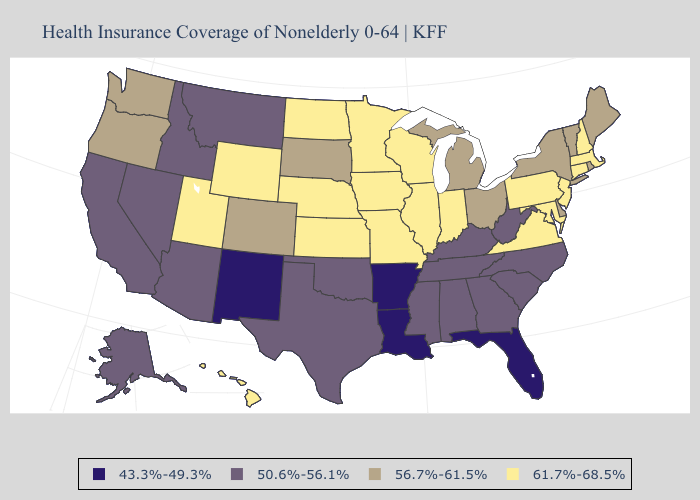What is the value of Montana?
Keep it brief. 50.6%-56.1%. Does the first symbol in the legend represent the smallest category?
Answer briefly. Yes. Name the states that have a value in the range 61.7%-68.5%?
Quick response, please. Connecticut, Hawaii, Illinois, Indiana, Iowa, Kansas, Maryland, Massachusetts, Minnesota, Missouri, Nebraska, New Hampshire, New Jersey, North Dakota, Pennsylvania, Utah, Virginia, Wisconsin, Wyoming. Among the states that border Arkansas , which have the highest value?
Concise answer only. Missouri. Does New York have the highest value in the Northeast?
Give a very brief answer. No. What is the highest value in states that border Oregon?
Answer briefly. 56.7%-61.5%. Does Arizona have a lower value than California?
Answer briefly. No. Does Idaho have the same value as Ohio?
Be succinct. No. What is the value of Montana?
Keep it brief. 50.6%-56.1%. Which states hav the highest value in the Northeast?
Write a very short answer. Connecticut, Massachusetts, New Hampshire, New Jersey, Pennsylvania. What is the value of Maryland?
Give a very brief answer. 61.7%-68.5%. Name the states that have a value in the range 61.7%-68.5%?
Quick response, please. Connecticut, Hawaii, Illinois, Indiana, Iowa, Kansas, Maryland, Massachusetts, Minnesota, Missouri, Nebraska, New Hampshire, New Jersey, North Dakota, Pennsylvania, Utah, Virginia, Wisconsin, Wyoming. What is the value of Virginia?
Give a very brief answer. 61.7%-68.5%. What is the value of Arkansas?
Write a very short answer. 43.3%-49.3%. Does the first symbol in the legend represent the smallest category?
Quick response, please. Yes. 